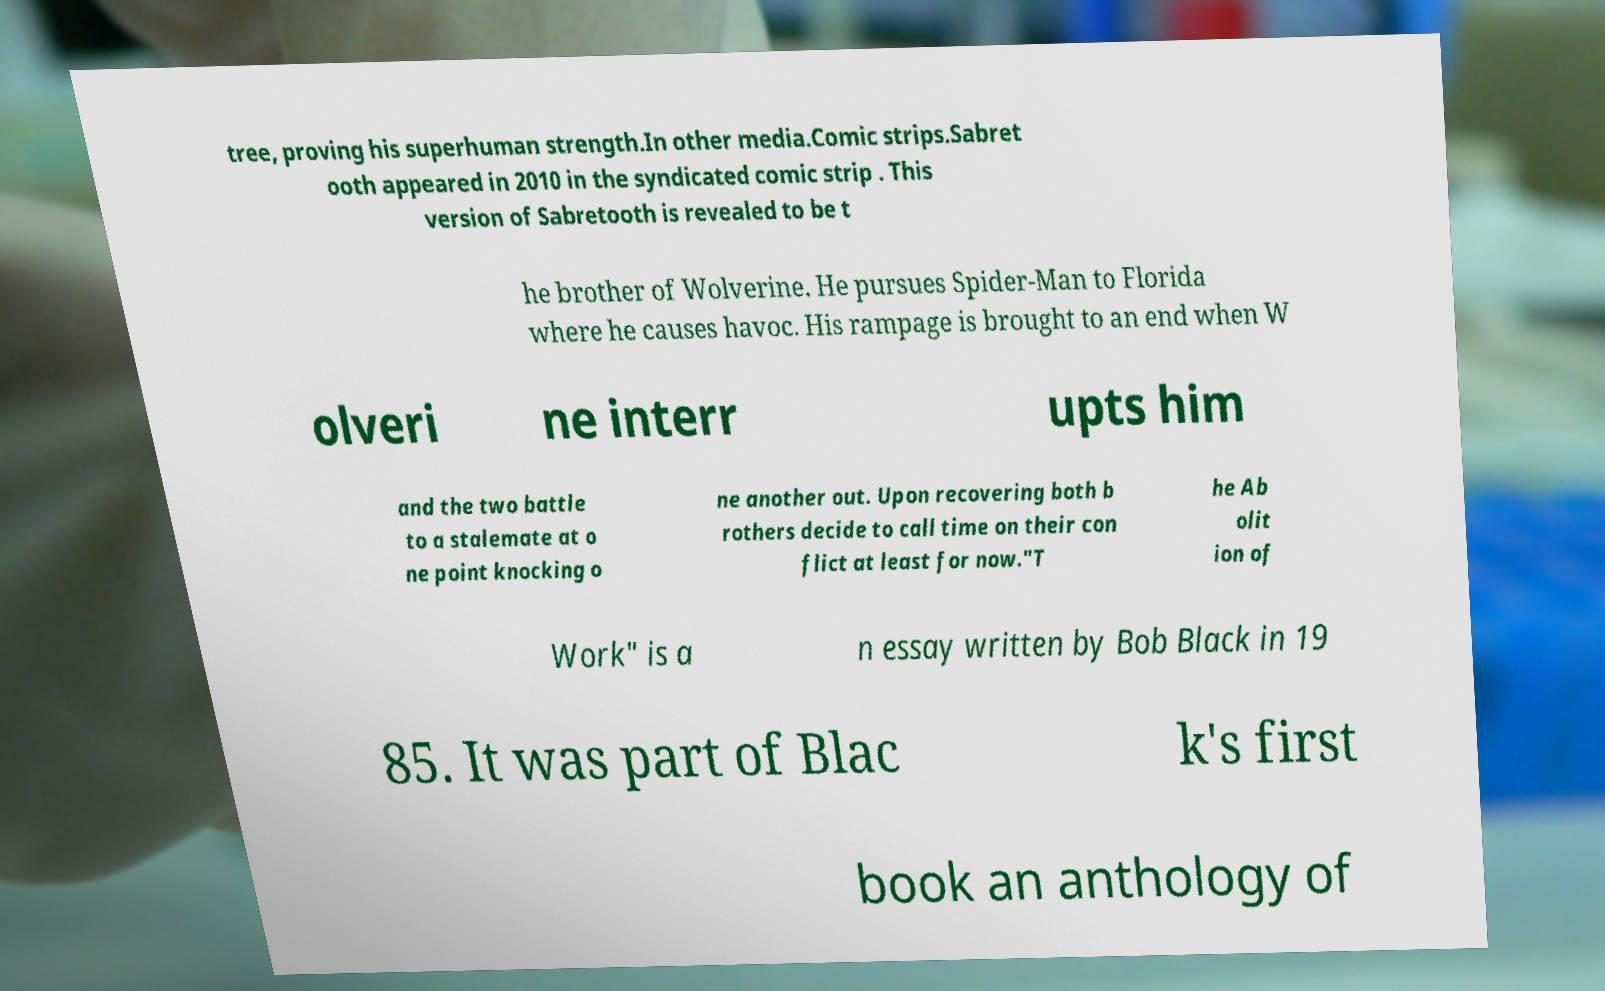Can you read and provide the text displayed in the image?This photo seems to have some interesting text. Can you extract and type it out for me? tree, proving his superhuman strength.In other media.Comic strips.Sabret ooth appeared in 2010 in the syndicated comic strip . This version of Sabretooth is revealed to be t he brother of Wolverine. He pursues Spider-Man to Florida where he causes havoc. His rampage is brought to an end when W olveri ne interr upts him and the two battle to a stalemate at o ne point knocking o ne another out. Upon recovering both b rothers decide to call time on their con flict at least for now."T he Ab olit ion of Work" is a n essay written by Bob Black in 19 85. It was part of Blac k's first book an anthology of 